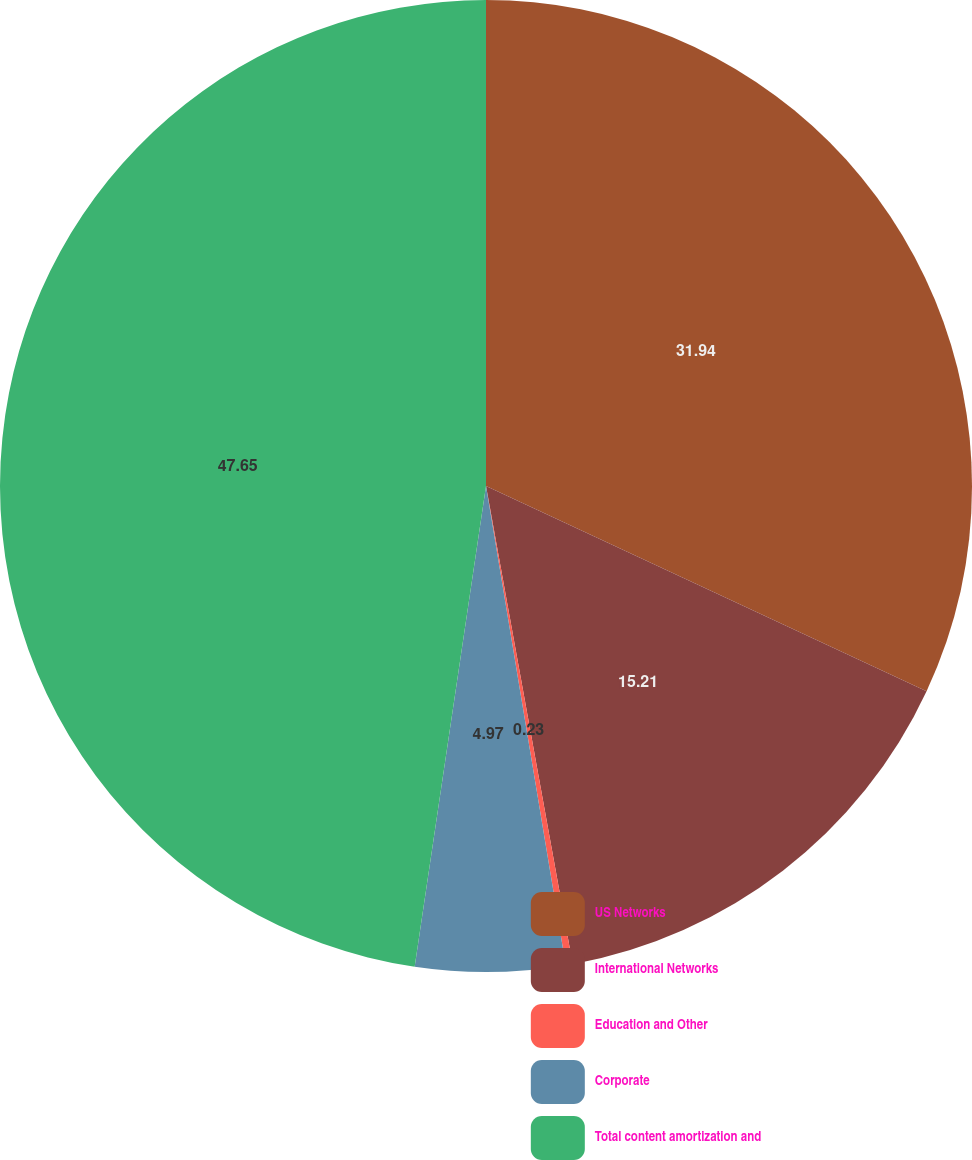<chart> <loc_0><loc_0><loc_500><loc_500><pie_chart><fcel>US Networks<fcel>International Networks<fcel>Education and Other<fcel>Corporate<fcel>Total content amortization and<nl><fcel>31.94%<fcel>15.21%<fcel>0.23%<fcel>4.97%<fcel>47.66%<nl></chart> 